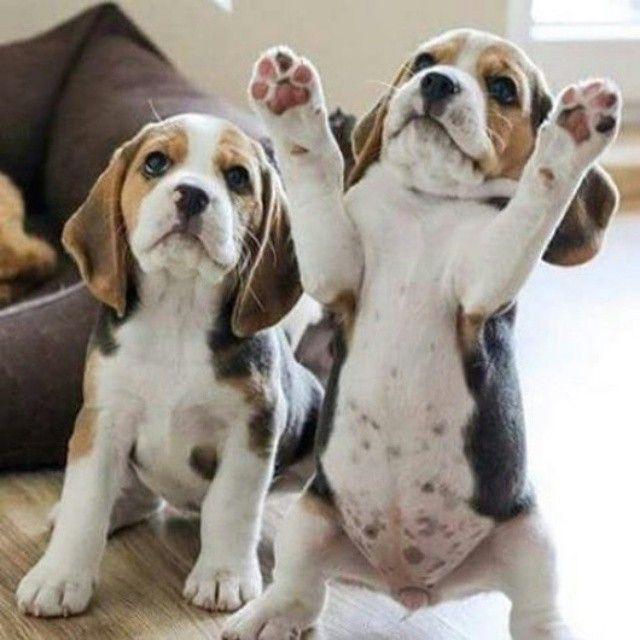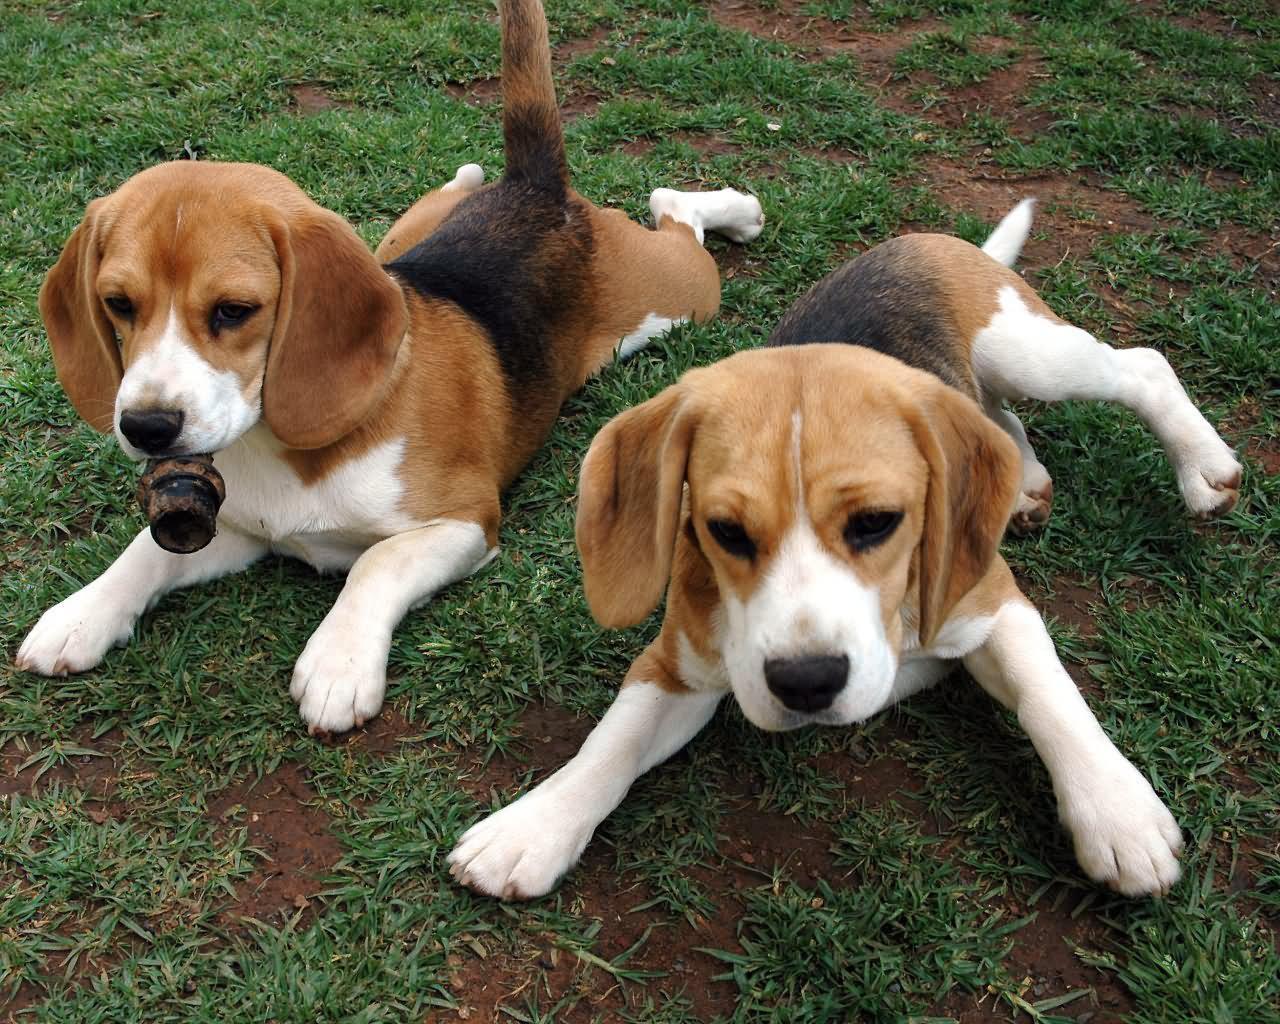The first image is the image on the left, the second image is the image on the right. Analyze the images presented: Is the assertion "There are two beagles in each image." valid? Answer yes or no. Yes. 